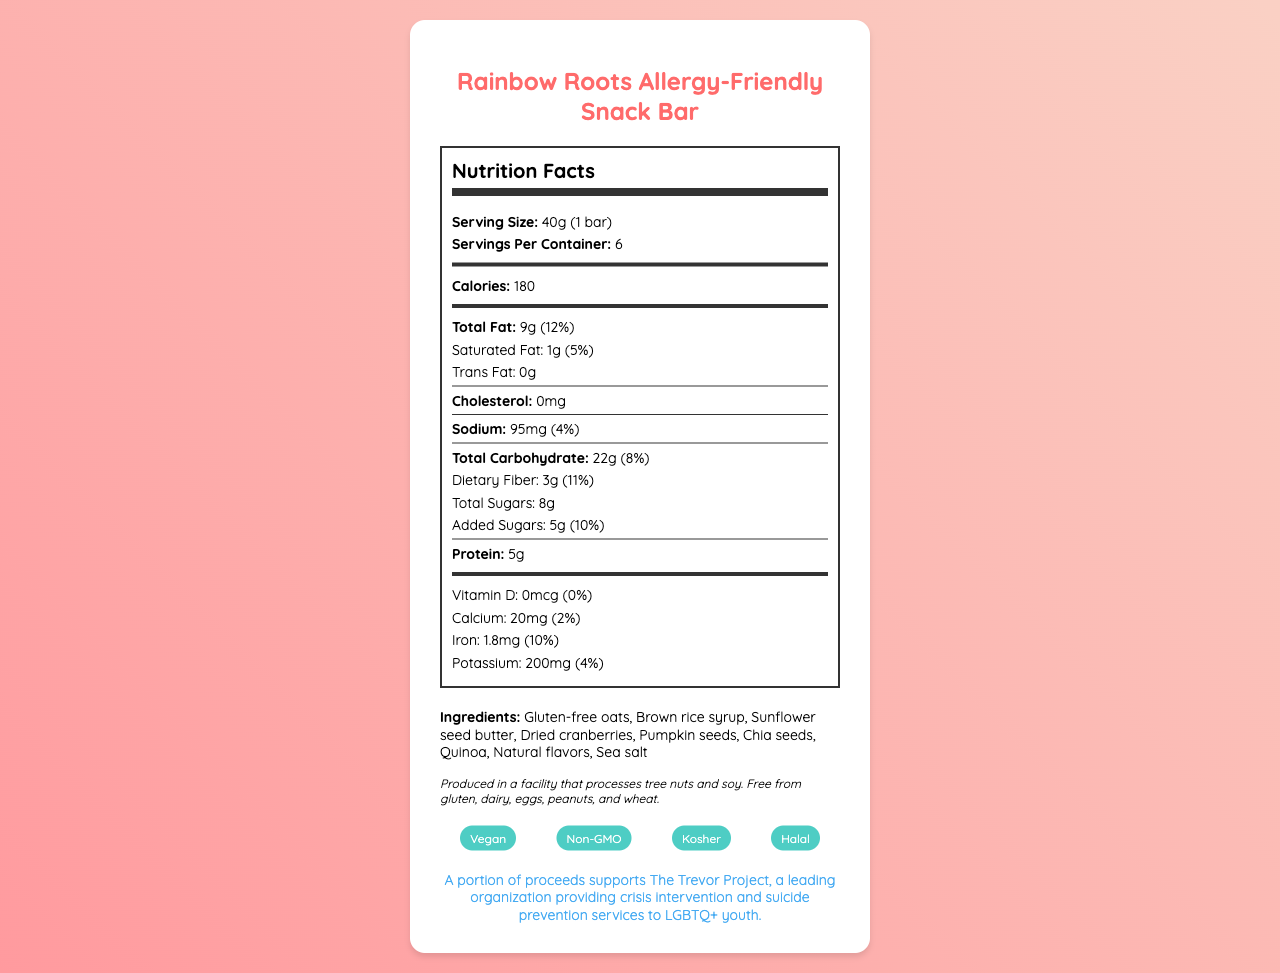what is the serving size? The serving size is listed in the Nutrition Facts section as "40g (1 bar)."
Answer: 40g (1 bar) how many servings are in a container? The document states that there are 6 servings per container.
Answer: 6 how many calories are there per serving? The document lists the calorie content as 180 per serving.
Answer: 180 how much protein is in one serving? The protein content per serving is stated as 5g.
Answer: 5g which ingredients are included in the snack bar? The ingredients list includes these specific items.
Answer: Gluten-free oats, Brown rice syrup, Sunflower seed butter, Dried cranberries, Pumpkin seeds, Chia seeds, Quinoa, Natural flavors, Sea salt what percentage of daily value is the total fat? According to the Nutrition Facts, the daily value percentage for total fat is 12%.
Answer: 12% what is the daily value of dietary fiber per serving? The document indicates the daily value of dietary fiber as 11%.
Answer: 11% how much added sugar is in the snack bar? The Nutrition Facts label shows that there are 5g of added sugars in the snack bar.
Answer: 5g what is stated about the vitamin D content? The document lists vitamin D content as 0mcg with a daily value of 0%.
Answer: 0mcg (0%) how much calcium does the snack bar contain? The snack bar contains 20mg of calcium, equating to 2% of the daily value.
Answer: 20mg (2%) Is the product vegan? The document specifically mentions that the product is vegan.
Answer: Yes which organization benefits from the product's proceeds? The social impact section states that a portion of proceeds supports The Trevor Project.
Answer: The Trevor Project what company manufactures the snack bar? The manufacturer is listed as Inclusive Eats, Inc.
Answer: Inclusive Eats, Inc. which nutrients are abundant in the snack bar? A. Vitamin D B. Iron C. Calcium D. Potassium Iron is listed at 1.8mg with a daily value of 10%, higher than the other minerals and vitamins listed.
Answer: B Does the snack bar contain gluten? The document specifies that the snack bar is free from gluten.
Answer: No what additional benefits does the product offer according to the document? The additional info section lists these benefits.
Answer: Vegan, Non-GMO, Kosher, Halal summarize the main idea of the document. The document is focused on providing detailed information about the Rainbow Roots snack bar, including its health benefits, support for LGBTQ+ youth, and inclusive values.
Answer: The document presents the Rainbow Roots Allergy-Friendly Snack Bar, highlighting its nutritional information, ingredients, allergen information, and special dietary benefits. It also emphasizes the product's support for The Trevor Project and the inclusive practices of the manufacturer, Inclusive Eats, Inc. what is the manufacturing date of the product? The document does not provide any information about the manufacturing date.
Answer: Cannot be determined 